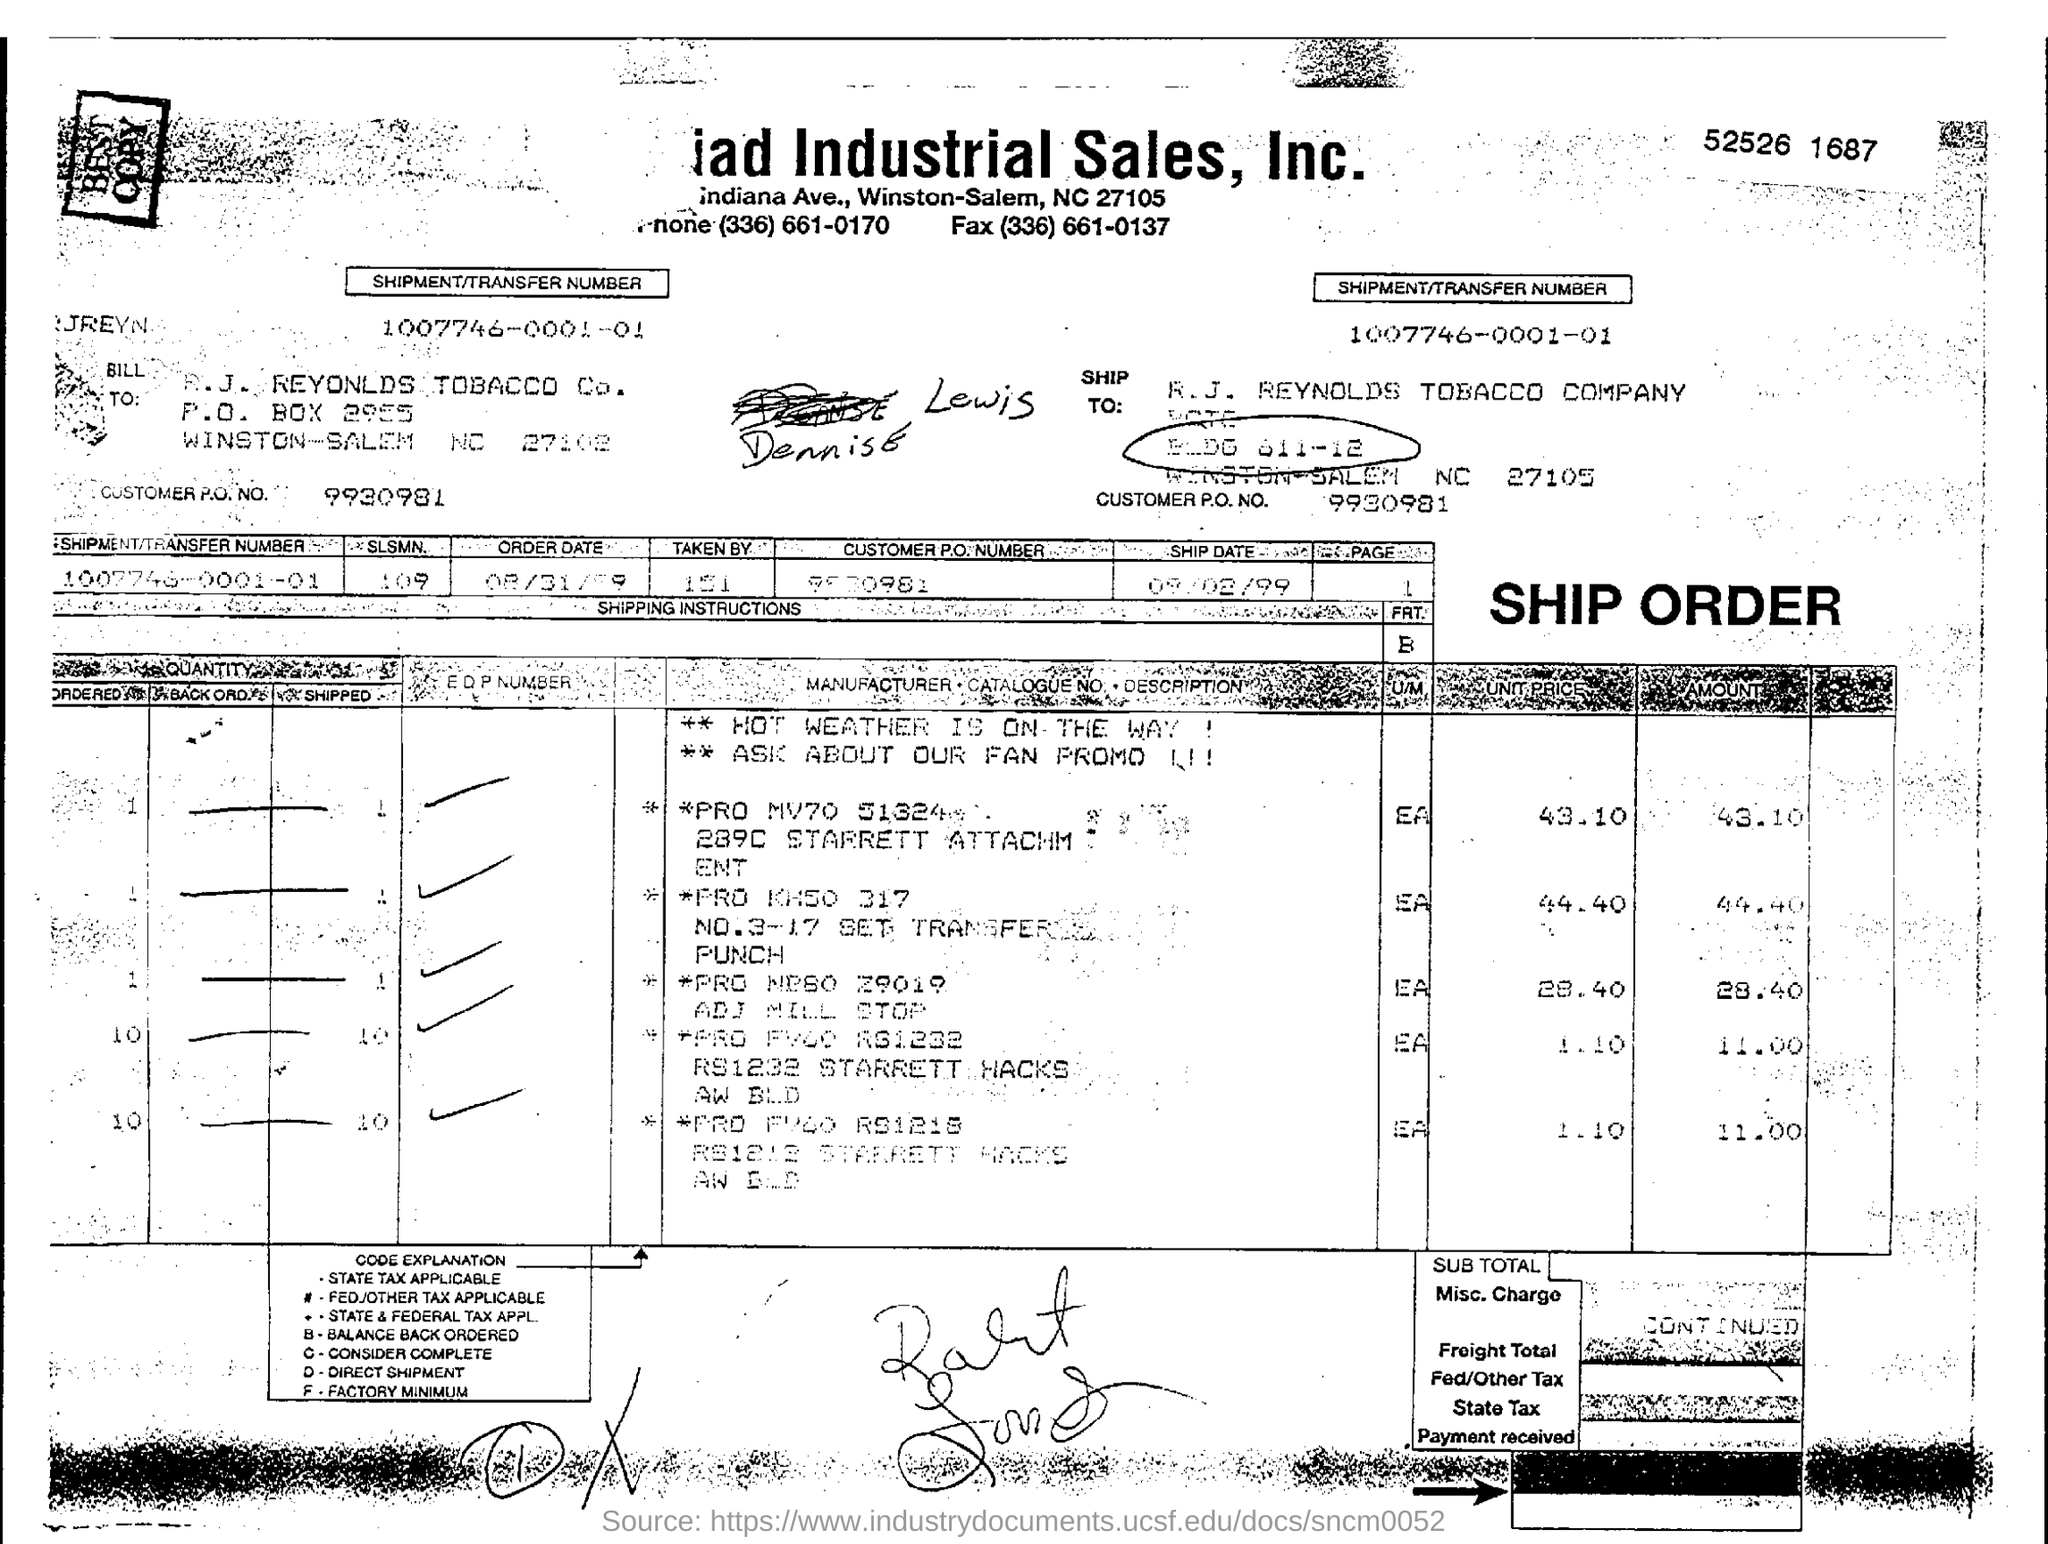What is the Shipment/Transfer Number mentioned in the document?
Ensure brevity in your answer.  1007746-0001-01. What is the Customer P.O. NO. given?
Give a very brief answer. 9930981. To which company , the shipment is made?
Ensure brevity in your answer.  R. J. REYNOLDS TOBACCO Co. 